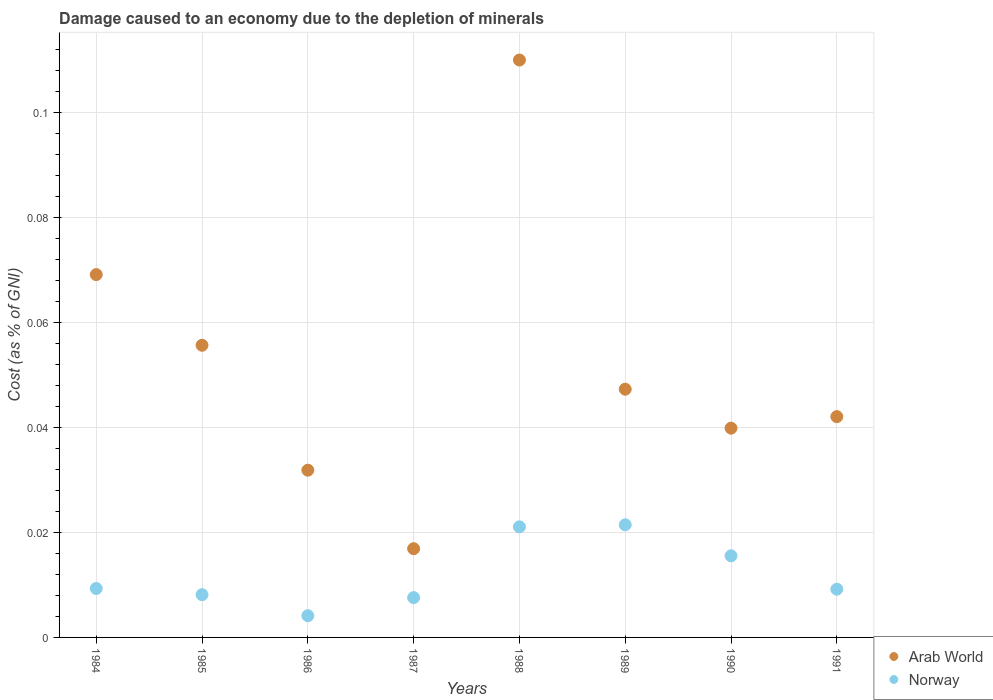Is the number of dotlines equal to the number of legend labels?
Ensure brevity in your answer.  Yes. What is the cost of damage caused due to the depletion of minerals in Arab World in 1984?
Offer a very short reply. 0.07. Across all years, what is the maximum cost of damage caused due to the depletion of minerals in Norway?
Make the answer very short. 0.02. Across all years, what is the minimum cost of damage caused due to the depletion of minerals in Arab World?
Your answer should be very brief. 0.02. In which year was the cost of damage caused due to the depletion of minerals in Norway minimum?
Your answer should be compact. 1986. What is the total cost of damage caused due to the depletion of minerals in Arab World in the graph?
Provide a short and direct response. 0.41. What is the difference between the cost of damage caused due to the depletion of minerals in Norway in 1984 and that in 1988?
Your response must be concise. -0.01. What is the difference between the cost of damage caused due to the depletion of minerals in Norway in 1991 and the cost of damage caused due to the depletion of minerals in Arab World in 1986?
Ensure brevity in your answer.  -0.02. What is the average cost of damage caused due to the depletion of minerals in Norway per year?
Your answer should be compact. 0.01. In the year 1990, what is the difference between the cost of damage caused due to the depletion of minerals in Norway and cost of damage caused due to the depletion of minerals in Arab World?
Your answer should be compact. -0.02. What is the ratio of the cost of damage caused due to the depletion of minerals in Norway in 1988 to that in 1991?
Offer a terse response. 2.29. Is the difference between the cost of damage caused due to the depletion of minerals in Norway in 1986 and 1989 greater than the difference between the cost of damage caused due to the depletion of minerals in Arab World in 1986 and 1989?
Ensure brevity in your answer.  No. What is the difference between the highest and the second highest cost of damage caused due to the depletion of minerals in Arab World?
Your response must be concise. 0.04. What is the difference between the highest and the lowest cost of damage caused due to the depletion of minerals in Arab World?
Keep it short and to the point. 0.09. Is the cost of damage caused due to the depletion of minerals in Norway strictly greater than the cost of damage caused due to the depletion of minerals in Arab World over the years?
Give a very brief answer. No. Is the cost of damage caused due to the depletion of minerals in Norway strictly less than the cost of damage caused due to the depletion of minerals in Arab World over the years?
Ensure brevity in your answer.  Yes. Does the graph contain any zero values?
Give a very brief answer. No. Does the graph contain grids?
Offer a very short reply. Yes. How many legend labels are there?
Your answer should be compact. 2. How are the legend labels stacked?
Offer a very short reply. Vertical. What is the title of the graph?
Offer a very short reply. Damage caused to an economy due to the depletion of minerals. What is the label or title of the X-axis?
Give a very brief answer. Years. What is the label or title of the Y-axis?
Keep it short and to the point. Cost (as % of GNI). What is the Cost (as % of GNI) of Arab World in 1984?
Keep it short and to the point. 0.07. What is the Cost (as % of GNI) in Norway in 1984?
Your answer should be very brief. 0.01. What is the Cost (as % of GNI) in Arab World in 1985?
Offer a very short reply. 0.06. What is the Cost (as % of GNI) in Norway in 1985?
Offer a terse response. 0.01. What is the Cost (as % of GNI) in Arab World in 1986?
Your response must be concise. 0.03. What is the Cost (as % of GNI) in Norway in 1986?
Keep it short and to the point. 0. What is the Cost (as % of GNI) of Arab World in 1987?
Give a very brief answer. 0.02. What is the Cost (as % of GNI) in Norway in 1987?
Your answer should be compact. 0.01. What is the Cost (as % of GNI) of Arab World in 1988?
Ensure brevity in your answer.  0.11. What is the Cost (as % of GNI) of Norway in 1988?
Your answer should be very brief. 0.02. What is the Cost (as % of GNI) of Arab World in 1989?
Make the answer very short. 0.05. What is the Cost (as % of GNI) of Norway in 1989?
Keep it short and to the point. 0.02. What is the Cost (as % of GNI) in Arab World in 1990?
Your answer should be very brief. 0.04. What is the Cost (as % of GNI) in Norway in 1990?
Offer a terse response. 0.02. What is the Cost (as % of GNI) in Arab World in 1991?
Offer a very short reply. 0.04. What is the Cost (as % of GNI) of Norway in 1991?
Provide a succinct answer. 0.01. Across all years, what is the maximum Cost (as % of GNI) of Arab World?
Make the answer very short. 0.11. Across all years, what is the maximum Cost (as % of GNI) of Norway?
Your answer should be very brief. 0.02. Across all years, what is the minimum Cost (as % of GNI) of Arab World?
Your answer should be very brief. 0.02. Across all years, what is the minimum Cost (as % of GNI) in Norway?
Keep it short and to the point. 0. What is the total Cost (as % of GNI) in Arab World in the graph?
Offer a very short reply. 0.41. What is the total Cost (as % of GNI) in Norway in the graph?
Your response must be concise. 0.1. What is the difference between the Cost (as % of GNI) of Arab World in 1984 and that in 1985?
Give a very brief answer. 0.01. What is the difference between the Cost (as % of GNI) in Norway in 1984 and that in 1985?
Keep it short and to the point. 0. What is the difference between the Cost (as % of GNI) of Arab World in 1984 and that in 1986?
Keep it short and to the point. 0.04. What is the difference between the Cost (as % of GNI) in Norway in 1984 and that in 1986?
Your answer should be compact. 0.01. What is the difference between the Cost (as % of GNI) in Arab World in 1984 and that in 1987?
Provide a short and direct response. 0.05. What is the difference between the Cost (as % of GNI) of Norway in 1984 and that in 1987?
Your response must be concise. 0. What is the difference between the Cost (as % of GNI) of Arab World in 1984 and that in 1988?
Provide a succinct answer. -0.04. What is the difference between the Cost (as % of GNI) of Norway in 1984 and that in 1988?
Give a very brief answer. -0.01. What is the difference between the Cost (as % of GNI) in Arab World in 1984 and that in 1989?
Keep it short and to the point. 0.02. What is the difference between the Cost (as % of GNI) in Norway in 1984 and that in 1989?
Provide a succinct answer. -0.01. What is the difference between the Cost (as % of GNI) in Arab World in 1984 and that in 1990?
Your answer should be compact. 0.03. What is the difference between the Cost (as % of GNI) in Norway in 1984 and that in 1990?
Give a very brief answer. -0.01. What is the difference between the Cost (as % of GNI) in Arab World in 1984 and that in 1991?
Your response must be concise. 0.03. What is the difference between the Cost (as % of GNI) in Norway in 1984 and that in 1991?
Your answer should be very brief. 0. What is the difference between the Cost (as % of GNI) of Arab World in 1985 and that in 1986?
Offer a terse response. 0.02. What is the difference between the Cost (as % of GNI) in Norway in 1985 and that in 1986?
Offer a very short reply. 0. What is the difference between the Cost (as % of GNI) in Arab World in 1985 and that in 1987?
Give a very brief answer. 0.04. What is the difference between the Cost (as % of GNI) in Norway in 1985 and that in 1987?
Ensure brevity in your answer.  0. What is the difference between the Cost (as % of GNI) in Arab World in 1985 and that in 1988?
Provide a succinct answer. -0.05. What is the difference between the Cost (as % of GNI) in Norway in 1985 and that in 1988?
Offer a very short reply. -0.01. What is the difference between the Cost (as % of GNI) of Arab World in 1985 and that in 1989?
Keep it short and to the point. 0.01. What is the difference between the Cost (as % of GNI) of Norway in 1985 and that in 1989?
Offer a terse response. -0.01. What is the difference between the Cost (as % of GNI) of Arab World in 1985 and that in 1990?
Ensure brevity in your answer.  0.02. What is the difference between the Cost (as % of GNI) in Norway in 1985 and that in 1990?
Your answer should be very brief. -0.01. What is the difference between the Cost (as % of GNI) of Arab World in 1985 and that in 1991?
Offer a terse response. 0.01. What is the difference between the Cost (as % of GNI) of Norway in 1985 and that in 1991?
Offer a terse response. -0. What is the difference between the Cost (as % of GNI) of Arab World in 1986 and that in 1987?
Your answer should be very brief. 0.01. What is the difference between the Cost (as % of GNI) in Norway in 1986 and that in 1987?
Your response must be concise. -0. What is the difference between the Cost (as % of GNI) in Arab World in 1986 and that in 1988?
Your response must be concise. -0.08. What is the difference between the Cost (as % of GNI) of Norway in 1986 and that in 1988?
Offer a terse response. -0.02. What is the difference between the Cost (as % of GNI) in Arab World in 1986 and that in 1989?
Ensure brevity in your answer.  -0.02. What is the difference between the Cost (as % of GNI) of Norway in 1986 and that in 1989?
Your response must be concise. -0.02. What is the difference between the Cost (as % of GNI) in Arab World in 1986 and that in 1990?
Provide a succinct answer. -0.01. What is the difference between the Cost (as % of GNI) of Norway in 1986 and that in 1990?
Provide a short and direct response. -0.01. What is the difference between the Cost (as % of GNI) in Arab World in 1986 and that in 1991?
Keep it short and to the point. -0.01. What is the difference between the Cost (as % of GNI) in Norway in 1986 and that in 1991?
Ensure brevity in your answer.  -0.01. What is the difference between the Cost (as % of GNI) of Arab World in 1987 and that in 1988?
Provide a succinct answer. -0.09. What is the difference between the Cost (as % of GNI) of Norway in 1987 and that in 1988?
Your response must be concise. -0.01. What is the difference between the Cost (as % of GNI) of Arab World in 1987 and that in 1989?
Offer a very short reply. -0.03. What is the difference between the Cost (as % of GNI) of Norway in 1987 and that in 1989?
Provide a short and direct response. -0.01. What is the difference between the Cost (as % of GNI) of Arab World in 1987 and that in 1990?
Your answer should be compact. -0.02. What is the difference between the Cost (as % of GNI) in Norway in 1987 and that in 1990?
Provide a short and direct response. -0.01. What is the difference between the Cost (as % of GNI) of Arab World in 1987 and that in 1991?
Offer a very short reply. -0.03. What is the difference between the Cost (as % of GNI) in Norway in 1987 and that in 1991?
Provide a short and direct response. -0. What is the difference between the Cost (as % of GNI) in Arab World in 1988 and that in 1989?
Offer a very short reply. 0.06. What is the difference between the Cost (as % of GNI) of Norway in 1988 and that in 1989?
Your response must be concise. -0. What is the difference between the Cost (as % of GNI) in Arab World in 1988 and that in 1990?
Ensure brevity in your answer.  0.07. What is the difference between the Cost (as % of GNI) in Norway in 1988 and that in 1990?
Your response must be concise. 0.01. What is the difference between the Cost (as % of GNI) in Arab World in 1988 and that in 1991?
Make the answer very short. 0.07. What is the difference between the Cost (as % of GNI) of Norway in 1988 and that in 1991?
Offer a terse response. 0.01. What is the difference between the Cost (as % of GNI) in Arab World in 1989 and that in 1990?
Offer a terse response. 0.01. What is the difference between the Cost (as % of GNI) in Norway in 1989 and that in 1990?
Provide a short and direct response. 0.01. What is the difference between the Cost (as % of GNI) of Arab World in 1989 and that in 1991?
Ensure brevity in your answer.  0.01. What is the difference between the Cost (as % of GNI) of Norway in 1989 and that in 1991?
Provide a succinct answer. 0.01. What is the difference between the Cost (as % of GNI) of Arab World in 1990 and that in 1991?
Provide a short and direct response. -0. What is the difference between the Cost (as % of GNI) of Norway in 1990 and that in 1991?
Your answer should be compact. 0.01. What is the difference between the Cost (as % of GNI) in Arab World in 1984 and the Cost (as % of GNI) in Norway in 1985?
Give a very brief answer. 0.06. What is the difference between the Cost (as % of GNI) in Arab World in 1984 and the Cost (as % of GNI) in Norway in 1986?
Your answer should be very brief. 0.07. What is the difference between the Cost (as % of GNI) in Arab World in 1984 and the Cost (as % of GNI) in Norway in 1987?
Provide a succinct answer. 0.06. What is the difference between the Cost (as % of GNI) in Arab World in 1984 and the Cost (as % of GNI) in Norway in 1988?
Keep it short and to the point. 0.05. What is the difference between the Cost (as % of GNI) of Arab World in 1984 and the Cost (as % of GNI) of Norway in 1989?
Your response must be concise. 0.05. What is the difference between the Cost (as % of GNI) of Arab World in 1984 and the Cost (as % of GNI) of Norway in 1990?
Make the answer very short. 0.05. What is the difference between the Cost (as % of GNI) in Arab World in 1984 and the Cost (as % of GNI) in Norway in 1991?
Make the answer very short. 0.06. What is the difference between the Cost (as % of GNI) of Arab World in 1985 and the Cost (as % of GNI) of Norway in 1986?
Ensure brevity in your answer.  0.05. What is the difference between the Cost (as % of GNI) of Arab World in 1985 and the Cost (as % of GNI) of Norway in 1987?
Provide a succinct answer. 0.05. What is the difference between the Cost (as % of GNI) of Arab World in 1985 and the Cost (as % of GNI) of Norway in 1988?
Ensure brevity in your answer.  0.03. What is the difference between the Cost (as % of GNI) of Arab World in 1985 and the Cost (as % of GNI) of Norway in 1989?
Make the answer very short. 0.03. What is the difference between the Cost (as % of GNI) in Arab World in 1985 and the Cost (as % of GNI) in Norway in 1990?
Make the answer very short. 0.04. What is the difference between the Cost (as % of GNI) in Arab World in 1985 and the Cost (as % of GNI) in Norway in 1991?
Offer a terse response. 0.05. What is the difference between the Cost (as % of GNI) in Arab World in 1986 and the Cost (as % of GNI) in Norway in 1987?
Ensure brevity in your answer.  0.02. What is the difference between the Cost (as % of GNI) in Arab World in 1986 and the Cost (as % of GNI) in Norway in 1988?
Ensure brevity in your answer.  0.01. What is the difference between the Cost (as % of GNI) of Arab World in 1986 and the Cost (as % of GNI) of Norway in 1989?
Your answer should be very brief. 0.01. What is the difference between the Cost (as % of GNI) in Arab World in 1986 and the Cost (as % of GNI) in Norway in 1990?
Provide a short and direct response. 0.02. What is the difference between the Cost (as % of GNI) in Arab World in 1986 and the Cost (as % of GNI) in Norway in 1991?
Make the answer very short. 0.02. What is the difference between the Cost (as % of GNI) of Arab World in 1987 and the Cost (as % of GNI) of Norway in 1988?
Keep it short and to the point. -0. What is the difference between the Cost (as % of GNI) in Arab World in 1987 and the Cost (as % of GNI) in Norway in 1989?
Make the answer very short. -0. What is the difference between the Cost (as % of GNI) of Arab World in 1987 and the Cost (as % of GNI) of Norway in 1990?
Make the answer very short. 0. What is the difference between the Cost (as % of GNI) in Arab World in 1987 and the Cost (as % of GNI) in Norway in 1991?
Make the answer very short. 0.01. What is the difference between the Cost (as % of GNI) of Arab World in 1988 and the Cost (as % of GNI) of Norway in 1989?
Your response must be concise. 0.09. What is the difference between the Cost (as % of GNI) in Arab World in 1988 and the Cost (as % of GNI) in Norway in 1990?
Your answer should be very brief. 0.09. What is the difference between the Cost (as % of GNI) in Arab World in 1988 and the Cost (as % of GNI) in Norway in 1991?
Your response must be concise. 0.1. What is the difference between the Cost (as % of GNI) of Arab World in 1989 and the Cost (as % of GNI) of Norway in 1990?
Make the answer very short. 0.03. What is the difference between the Cost (as % of GNI) in Arab World in 1989 and the Cost (as % of GNI) in Norway in 1991?
Make the answer very short. 0.04. What is the difference between the Cost (as % of GNI) in Arab World in 1990 and the Cost (as % of GNI) in Norway in 1991?
Your response must be concise. 0.03. What is the average Cost (as % of GNI) in Arab World per year?
Make the answer very short. 0.05. What is the average Cost (as % of GNI) of Norway per year?
Your answer should be compact. 0.01. In the year 1984, what is the difference between the Cost (as % of GNI) of Arab World and Cost (as % of GNI) of Norway?
Provide a succinct answer. 0.06. In the year 1985, what is the difference between the Cost (as % of GNI) of Arab World and Cost (as % of GNI) of Norway?
Offer a terse response. 0.05. In the year 1986, what is the difference between the Cost (as % of GNI) in Arab World and Cost (as % of GNI) in Norway?
Offer a terse response. 0.03. In the year 1987, what is the difference between the Cost (as % of GNI) in Arab World and Cost (as % of GNI) in Norway?
Keep it short and to the point. 0.01. In the year 1988, what is the difference between the Cost (as % of GNI) of Arab World and Cost (as % of GNI) of Norway?
Provide a succinct answer. 0.09. In the year 1989, what is the difference between the Cost (as % of GNI) in Arab World and Cost (as % of GNI) in Norway?
Your answer should be very brief. 0.03. In the year 1990, what is the difference between the Cost (as % of GNI) in Arab World and Cost (as % of GNI) in Norway?
Offer a very short reply. 0.02. In the year 1991, what is the difference between the Cost (as % of GNI) of Arab World and Cost (as % of GNI) of Norway?
Make the answer very short. 0.03. What is the ratio of the Cost (as % of GNI) in Arab World in 1984 to that in 1985?
Your answer should be compact. 1.24. What is the ratio of the Cost (as % of GNI) in Norway in 1984 to that in 1985?
Your answer should be very brief. 1.15. What is the ratio of the Cost (as % of GNI) in Arab World in 1984 to that in 1986?
Give a very brief answer. 2.17. What is the ratio of the Cost (as % of GNI) in Norway in 1984 to that in 1986?
Provide a succinct answer. 2.25. What is the ratio of the Cost (as % of GNI) of Arab World in 1984 to that in 1987?
Your response must be concise. 4.09. What is the ratio of the Cost (as % of GNI) in Norway in 1984 to that in 1987?
Ensure brevity in your answer.  1.23. What is the ratio of the Cost (as % of GNI) in Arab World in 1984 to that in 1988?
Offer a very short reply. 0.63. What is the ratio of the Cost (as % of GNI) of Norway in 1984 to that in 1988?
Your answer should be compact. 0.44. What is the ratio of the Cost (as % of GNI) of Arab World in 1984 to that in 1989?
Make the answer very short. 1.46. What is the ratio of the Cost (as % of GNI) in Norway in 1984 to that in 1989?
Provide a short and direct response. 0.43. What is the ratio of the Cost (as % of GNI) of Arab World in 1984 to that in 1990?
Your response must be concise. 1.73. What is the ratio of the Cost (as % of GNI) in Norway in 1984 to that in 1990?
Give a very brief answer. 0.6. What is the ratio of the Cost (as % of GNI) of Arab World in 1984 to that in 1991?
Provide a short and direct response. 1.64. What is the ratio of the Cost (as % of GNI) in Norway in 1984 to that in 1991?
Your answer should be very brief. 1.01. What is the ratio of the Cost (as % of GNI) in Arab World in 1985 to that in 1986?
Make the answer very short. 1.75. What is the ratio of the Cost (as % of GNI) of Norway in 1985 to that in 1986?
Offer a very short reply. 1.97. What is the ratio of the Cost (as % of GNI) in Arab World in 1985 to that in 1987?
Your answer should be compact. 3.29. What is the ratio of the Cost (as % of GNI) in Norway in 1985 to that in 1987?
Your response must be concise. 1.07. What is the ratio of the Cost (as % of GNI) of Arab World in 1985 to that in 1988?
Your answer should be compact. 0.51. What is the ratio of the Cost (as % of GNI) in Norway in 1985 to that in 1988?
Offer a very short reply. 0.39. What is the ratio of the Cost (as % of GNI) of Arab World in 1985 to that in 1989?
Ensure brevity in your answer.  1.18. What is the ratio of the Cost (as % of GNI) of Norway in 1985 to that in 1989?
Give a very brief answer. 0.38. What is the ratio of the Cost (as % of GNI) of Arab World in 1985 to that in 1990?
Provide a short and direct response. 1.4. What is the ratio of the Cost (as % of GNI) of Norway in 1985 to that in 1990?
Your answer should be very brief. 0.52. What is the ratio of the Cost (as % of GNI) of Arab World in 1985 to that in 1991?
Provide a succinct answer. 1.32. What is the ratio of the Cost (as % of GNI) of Norway in 1985 to that in 1991?
Offer a very short reply. 0.89. What is the ratio of the Cost (as % of GNI) of Arab World in 1986 to that in 1987?
Give a very brief answer. 1.88. What is the ratio of the Cost (as % of GNI) of Norway in 1986 to that in 1987?
Provide a succinct answer. 0.55. What is the ratio of the Cost (as % of GNI) in Arab World in 1986 to that in 1988?
Offer a terse response. 0.29. What is the ratio of the Cost (as % of GNI) in Norway in 1986 to that in 1988?
Keep it short and to the point. 0.2. What is the ratio of the Cost (as % of GNI) of Arab World in 1986 to that in 1989?
Provide a succinct answer. 0.67. What is the ratio of the Cost (as % of GNI) of Norway in 1986 to that in 1989?
Give a very brief answer. 0.19. What is the ratio of the Cost (as % of GNI) in Arab World in 1986 to that in 1990?
Provide a succinct answer. 0.8. What is the ratio of the Cost (as % of GNI) in Norway in 1986 to that in 1990?
Your response must be concise. 0.27. What is the ratio of the Cost (as % of GNI) of Arab World in 1986 to that in 1991?
Offer a terse response. 0.76. What is the ratio of the Cost (as % of GNI) of Norway in 1986 to that in 1991?
Offer a terse response. 0.45. What is the ratio of the Cost (as % of GNI) of Arab World in 1987 to that in 1988?
Ensure brevity in your answer.  0.15. What is the ratio of the Cost (as % of GNI) in Norway in 1987 to that in 1988?
Offer a terse response. 0.36. What is the ratio of the Cost (as % of GNI) in Arab World in 1987 to that in 1989?
Keep it short and to the point. 0.36. What is the ratio of the Cost (as % of GNI) in Norway in 1987 to that in 1989?
Your answer should be compact. 0.35. What is the ratio of the Cost (as % of GNI) in Arab World in 1987 to that in 1990?
Offer a very short reply. 0.42. What is the ratio of the Cost (as % of GNI) of Norway in 1987 to that in 1990?
Your answer should be compact. 0.49. What is the ratio of the Cost (as % of GNI) of Arab World in 1987 to that in 1991?
Your answer should be very brief. 0.4. What is the ratio of the Cost (as % of GNI) of Norway in 1987 to that in 1991?
Your answer should be compact. 0.82. What is the ratio of the Cost (as % of GNI) in Arab World in 1988 to that in 1989?
Keep it short and to the point. 2.33. What is the ratio of the Cost (as % of GNI) of Norway in 1988 to that in 1989?
Make the answer very short. 0.98. What is the ratio of the Cost (as % of GNI) in Arab World in 1988 to that in 1990?
Offer a terse response. 2.76. What is the ratio of the Cost (as % of GNI) in Norway in 1988 to that in 1990?
Make the answer very short. 1.35. What is the ratio of the Cost (as % of GNI) in Arab World in 1988 to that in 1991?
Provide a succinct answer. 2.62. What is the ratio of the Cost (as % of GNI) of Norway in 1988 to that in 1991?
Provide a short and direct response. 2.29. What is the ratio of the Cost (as % of GNI) of Arab World in 1989 to that in 1990?
Offer a very short reply. 1.19. What is the ratio of the Cost (as % of GNI) of Norway in 1989 to that in 1990?
Your response must be concise. 1.38. What is the ratio of the Cost (as % of GNI) of Arab World in 1989 to that in 1991?
Your answer should be compact. 1.12. What is the ratio of the Cost (as % of GNI) of Norway in 1989 to that in 1991?
Ensure brevity in your answer.  2.33. What is the ratio of the Cost (as % of GNI) in Arab World in 1990 to that in 1991?
Provide a succinct answer. 0.95. What is the ratio of the Cost (as % of GNI) of Norway in 1990 to that in 1991?
Your answer should be compact. 1.69. What is the difference between the highest and the second highest Cost (as % of GNI) of Arab World?
Give a very brief answer. 0.04. What is the difference between the highest and the lowest Cost (as % of GNI) of Arab World?
Your answer should be compact. 0.09. What is the difference between the highest and the lowest Cost (as % of GNI) in Norway?
Offer a very short reply. 0.02. 